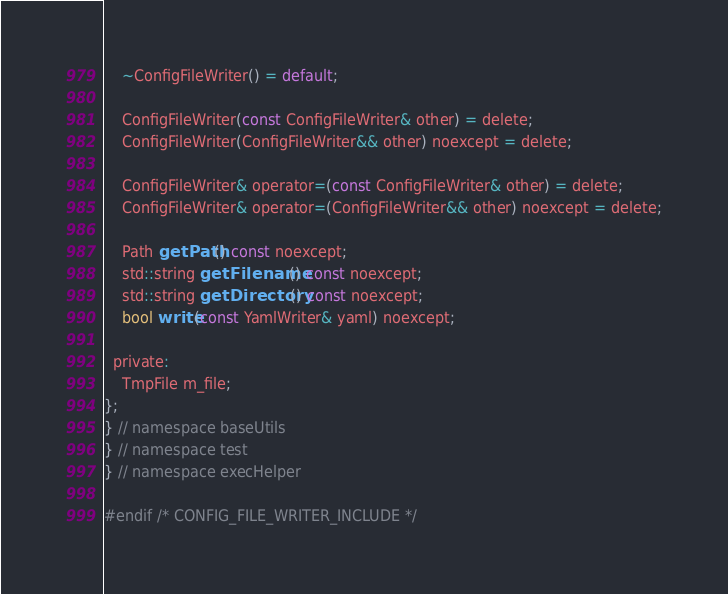<code> <loc_0><loc_0><loc_500><loc_500><_C_>    ~ConfigFileWriter() = default;

    ConfigFileWriter(const ConfigFileWriter& other) = delete;
    ConfigFileWriter(ConfigFileWriter&& other) noexcept = delete;

    ConfigFileWriter& operator=(const ConfigFileWriter& other) = delete;
    ConfigFileWriter& operator=(ConfigFileWriter&& other) noexcept = delete;

    Path getPath() const noexcept;
    std::string getFilename() const noexcept;
    std::string getDirectory() const noexcept;
    bool write(const YamlWriter& yaml) noexcept;

  private:
    TmpFile m_file;
};
} // namespace baseUtils
} // namespace test
} // namespace execHelper

#endif /* CONFIG_FILE_WRITER_INCLUDE */
</code> 